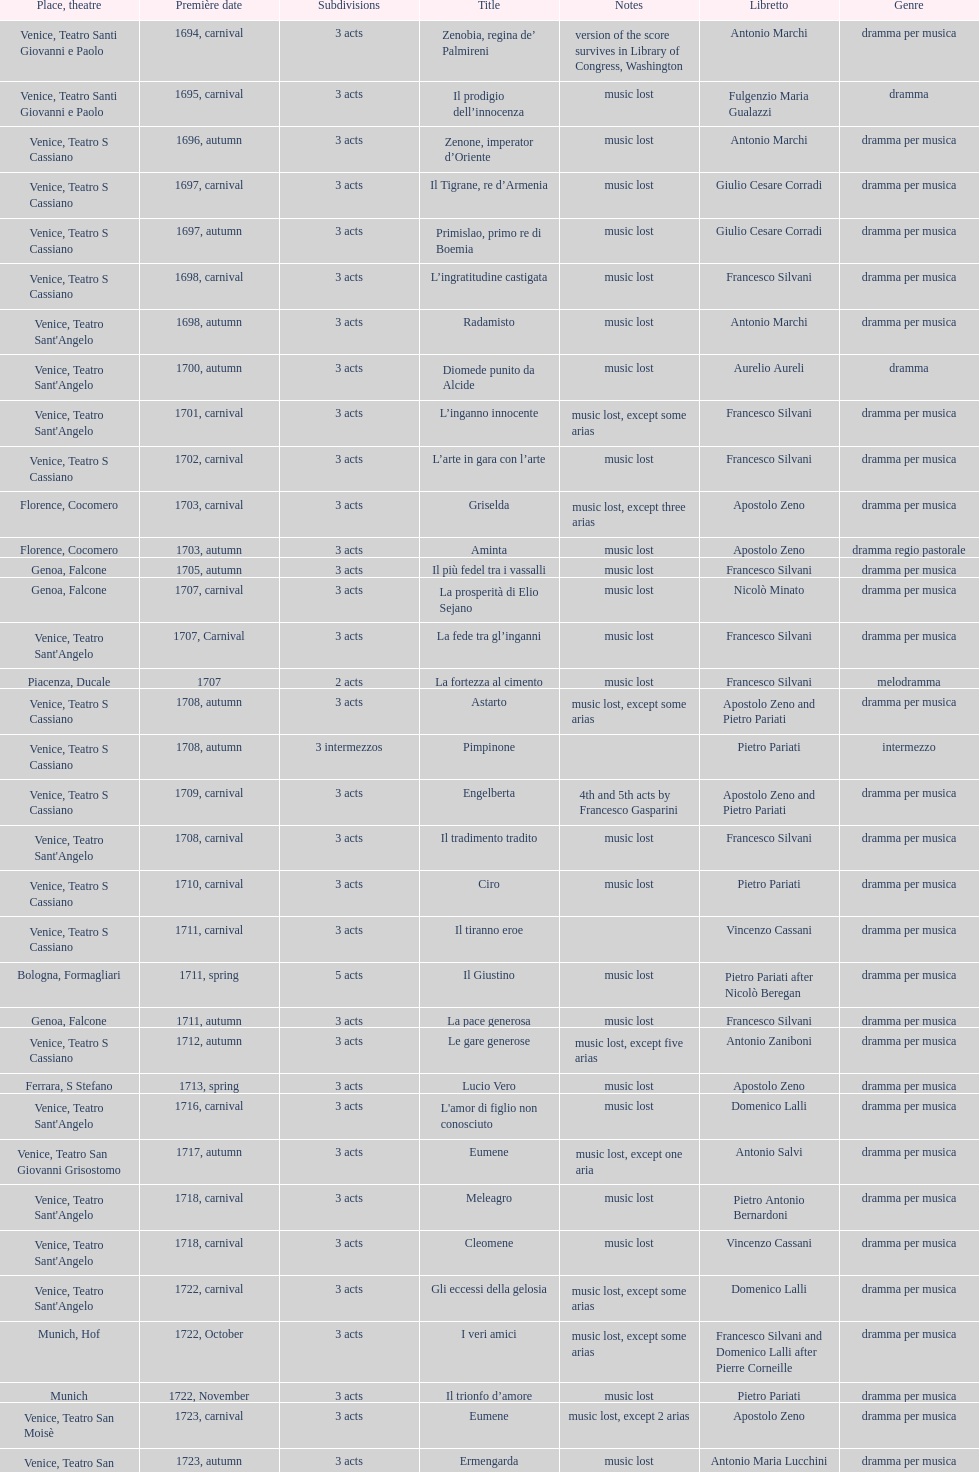Which was released earlier, artamene or merope? Merope. 